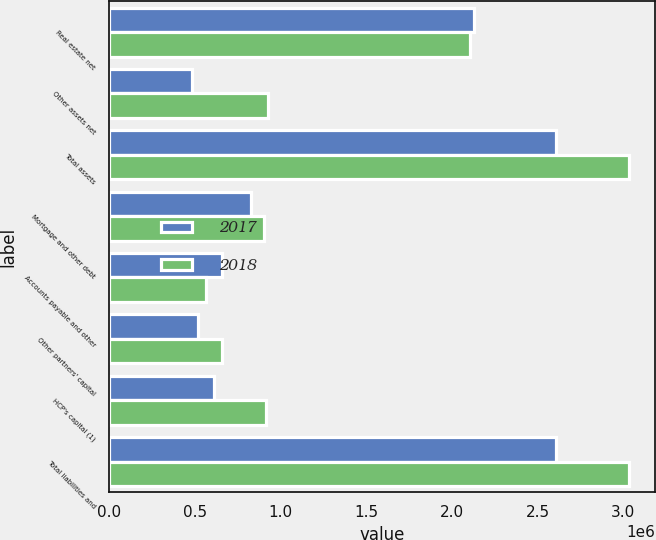<chart> <loc_0><loc_0><loc_500><loc_500><stacked_bar_chart><ecel><fcel>Real estate net<fcel>Other assets net<fcel>Total assets<fcel>Mortgage and other debt<fcel>Accounts payable and other<fcel>Other partners' capital<fcel>HCP's capital (1)<fcel>Total liabilities and<nl><fcel>2017<fcel>2.12815e+06<fcel>479935<fcel>2.60808e+06<fcel>827622<fcel>655177<fcel>515791<fcel>609492<fcel>2.60808e+06<nl><fcel>2018<fcel>2.10409e+06<fcel>928790<fcel>3.03288e+06<fcel>900911<fcel>561523<fcel>655311<fcel>915135<fcel>3.03288e+06<nl></chart> 